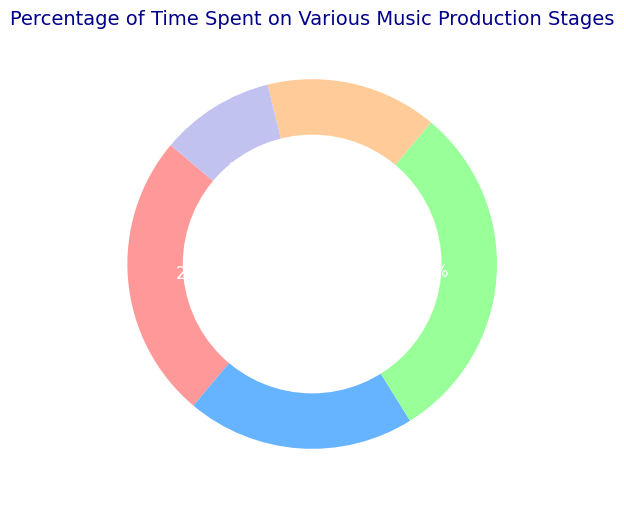What percentage of time is spent on Mixing compared to Mastering? To determine the percentage of time spent on Mixing compared to Mastering, you look at the individual percentages: Mixing is 15% and Mastering is 10%. No calculations needed just a direct comparison
Answer: 15% is greater than 10% Which stage requires the most time in the music production process? By examining the pie chart, the stage with the largest slice is the one with the highest percentage. Here, Editing occupies 30% of the chart
Answer: Editing What is the combined percentage of time spent on Composing and Recording? To find the combined percentage, you simply add the individual percentages for Composing (25%) and Recording (20%): 25% + 20% = 45%
Answer: 45% What is the difference between the percentage of time spent on Editing and the time spent on Mastering? Subtract the percentage of time spent on Mastering (10%) from the percentage of time spent on Editing (30%): 30% - 10% = 20%
Answer: 20% Which stage has the smallest slice in the pie chart? By looking at the pie chart, you observe that the segment for Mastering is the smallest, representing the lowest percentage
Answer: Mastering How many stages spend less time than Recording? Identify the percentages less than that of Recording (20%): Mixing (15%) and Mastering (10%). Count these stages: 2 stages
Answer: 2 Is the combined percentage of time for Composing and Mixing greater than the time spent on Editing? First, calculate the combined percentage of Composing (25%) and Mixing (15%): 25% + 15% = 40%. Then, compare it to Editing (30%). Since 40% > 30%, it's greater
Answer: Yes What color represents the Editing stage in the pie chart? By examining the colors assigned in the pie chart, you identify that Editing is represented by the color #99ff99 which translates to a shade of green
Answer: Green What ratio does the time spent on Recording represent out of the total production process? The percentage spent on Recording is 20%. This can be expressed as a ratio of 20:100, which simplifies to 1:5
Answer: 1:5 How many stages have a percentage representation above 20%? Identify the stages with a percentage greater than 20%. Here, Composing (25%) and Editing (30%) meet the criterion. Count these stages: 2 stages
Answer: 2 